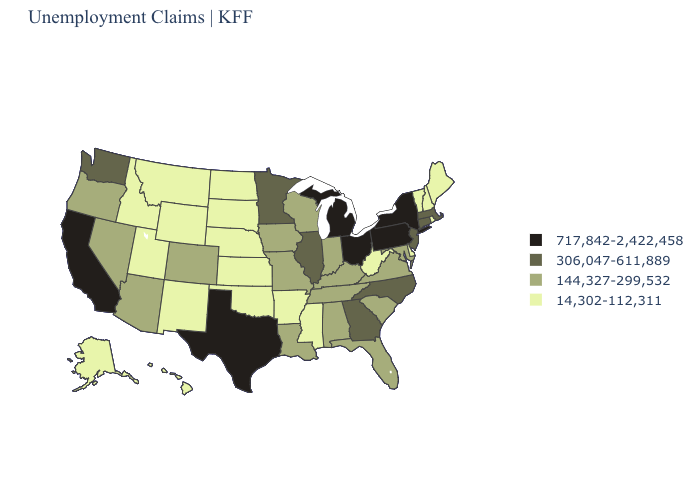What is the lowest value in states that border Vermont?
Quick response, please. 14,302-112,311. Which states have the lowest value in the USA?
Write a very short answer. Alaska, Arkansas, Delaware, Hawaii, Idaho, Kansas, Maine, Mississippi, Montana, Nebraska, New Hampshire, New Mexico, North Dakota, Oklahoma, Rhode Island, South Dakota, Utah, Vermont, West Virginia, Wyoming. Name the states that have a value in the range 14,302-112,311?
Concise answer only. Alaska, Arkansas, Delaware, Hawaii, Idaho, Kansas, Maine, Mississippi, Montana, Nebraska, New Hampshire, New Mexico, North Dakota, Oklahoma, Rhode Island, South Dakota, Utah, Vermont, West Virginia, Wyoming. Name the states that have a value in the range 717,842-2,422,458?
Give a very brief answer. California, Michigan, New York, Ohio, Pennsylvania, Texas. Name the states that have a value in the range 717,842-2,422,458?
Concise answer only. California, Michigan, New York, Ohio, Pennsylvania, Texas. What is the lowest value in the South?
Short answer required. 14,302-112,311. Does Massachusetts have a lower value than Texas?
Write a very short answer. Yes. What is the lowest value in the USA?
Keep it brief. 14,302-112,311. Does Tennessee have the lowest value in the USA?
Be succinct. No. Among the states that border Alabama , which have the highest value?
Keep it brief. Georgia. What is the highest value in the USA?
Write a very short answer. 717,842-2,422,458. Which states have the highest value in the USA?
Short answer required. California, Michigan, New York, Ohio, Pennsylvania, Texas. Name the states that have a value in the range 14,302-112,311?
Answer briefly. Alaska, Arkansas, Delaware, Hawaii, Idaho, Kansas, Maine, Mississippi, Montana, Nebraska, New Hampshire, New Mexico, North Dakota, Oklahoma, Rhode Island, South Dakota, Utah, Vermont, West Virginia, Wyoming. Does the map have missing data?
Keep it brief. No. Does the map have missing data?
Short answer required. No. 